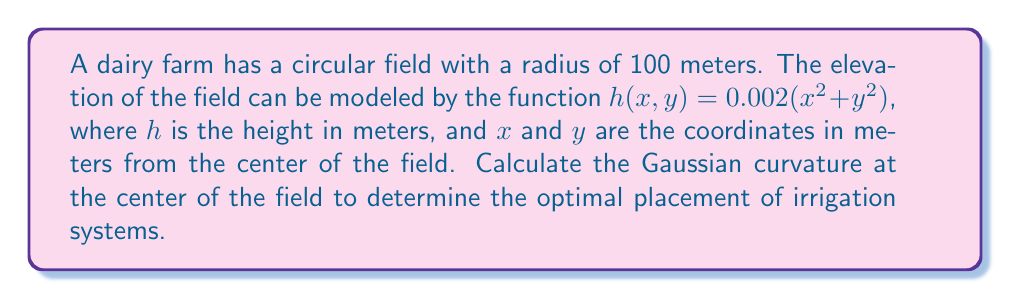Show me your answer to this math problem. To calculate the Gaussian curvature at the center of the field, we'll follow these steps:

1) The Gaussian curvature $K$ is given by:

   $K = \frac{f_{xx}f_{yy} - f_{xy}^2}{(1 + f_x^2 + f_y^2)^2}$

   where $f_{xx}, f_{yy}, f_{xy}, f_x,$ and $f_y$ are the second and first partial derivatives of $h(x,y)$.

2) Calculate the partial derivatives:
   
   $f_x = \frac{\partial h}{\partial x} = 0.004x$
   $f_y = \frac{\partial h}{\partial y} = 0.004y$
   
   $f_{xx} = \frac{\partial^2 h}{\partial x^2} = 0.004$
   $f_{yy} = \frac{\partial^2 h}{\partial y^2} = 0.004$
   $f_{xy} = \frac{\partial^2 h}{\partial x \partial y} = 0$

3) At the center of the field, $(x,y) = (0,0)$. Substitute these values:

   $f_x(0,0) = 0$
   $f_y(0,0) = 0$
   $f_{xx}(0,0) = 0.004$
   $f_{yy}(0,0) = 0.004$
   $f_{xy}(0,0) = 0$

4) Now, substitute these values into the Gaussian curvature formula:

   $K = \frac{(0.004)(0.004) - 0^2}{(1 + 0^2 + 0^2)^2}$

5) Simplify:

   $K = \frac{0.000016}{1} = 0.000016 \text{ m}^{-2}$
Answer: $0.000016 \text{ m}^{-2}$ 